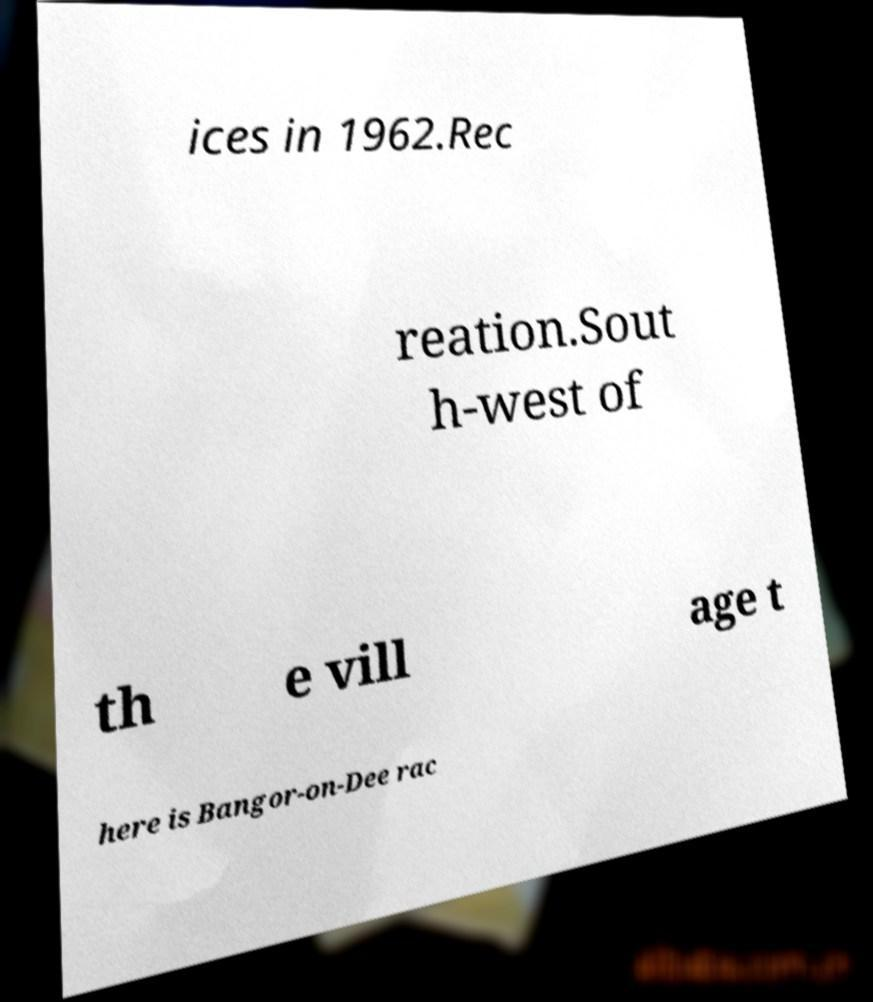I need the written content from this picture converted into text. Can you do that? ices in 1962.Rec reation.Sout h-west of th e vill age t here is Bangor-on-Dee rac 